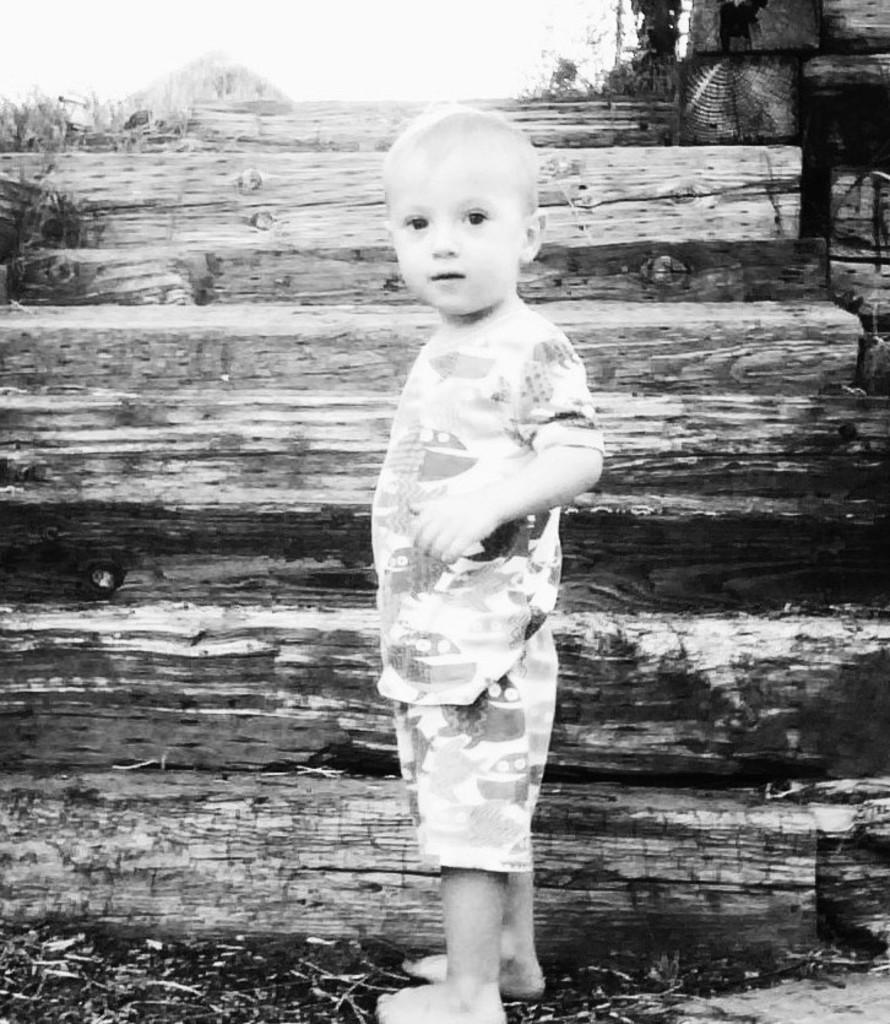What is the color scheme of the image? The image is black and white. What is the main subject of the image? There is a kid standing in the middle of the image. What can be seen in the background of the image? There are wooden stairs in the background of the image. What arithmetic problem is the kid solving in the image? There is no indication in the image that the kid is solving an arithmetic problem. What is the moon's position in the image? The moon is not visible in the image, as it is a black and white image with no celestial objects present. 